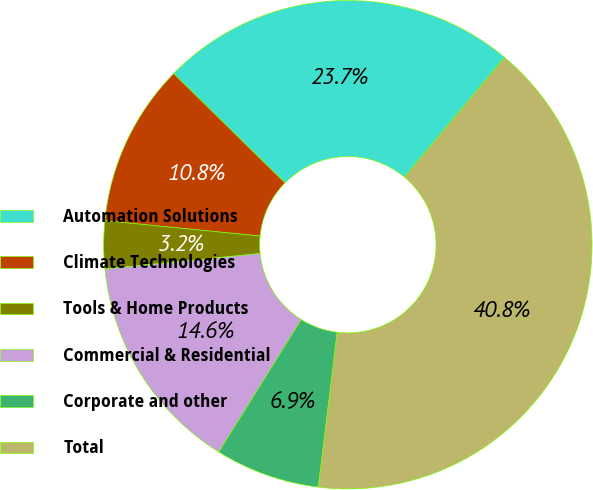<chart> <loc_0><loc_0><loc_500><loc_500><pie_chart><fcel>Automation Solutions<fcel>Climate Technologies<fcel>Tools & Home Products<fcel>Commercial & Residential<fcel>Corporate and other<fcel>Total<nl><fcel>23.73%<fcel>10.79%<fcel>3.16%<fcel>14.55%<fcel>6.93%<fcel>40.84%<nl></chart> 